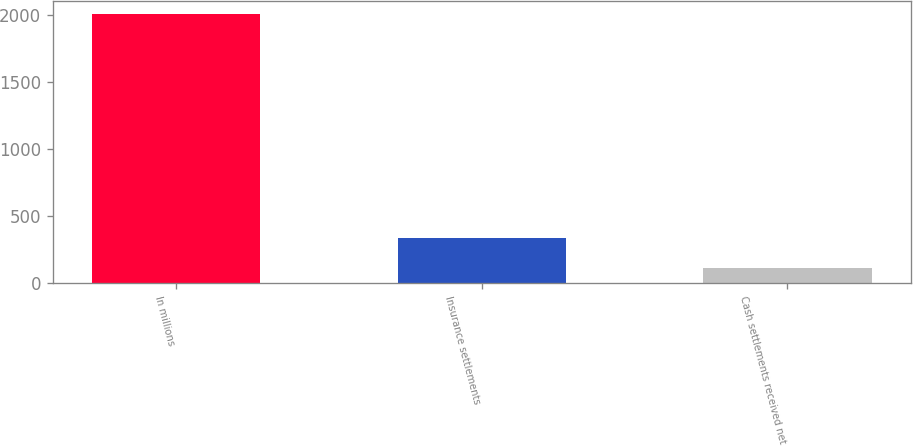Convert chart. <chart><loc_0><loc_0><loc_500><loc_500><bar_chart><fcel>In millions<fcel>Insurance settlements<fcel>Cash settlements received net<nl><fcel>2005<fcel>334<fcel>114<nl></chart> 